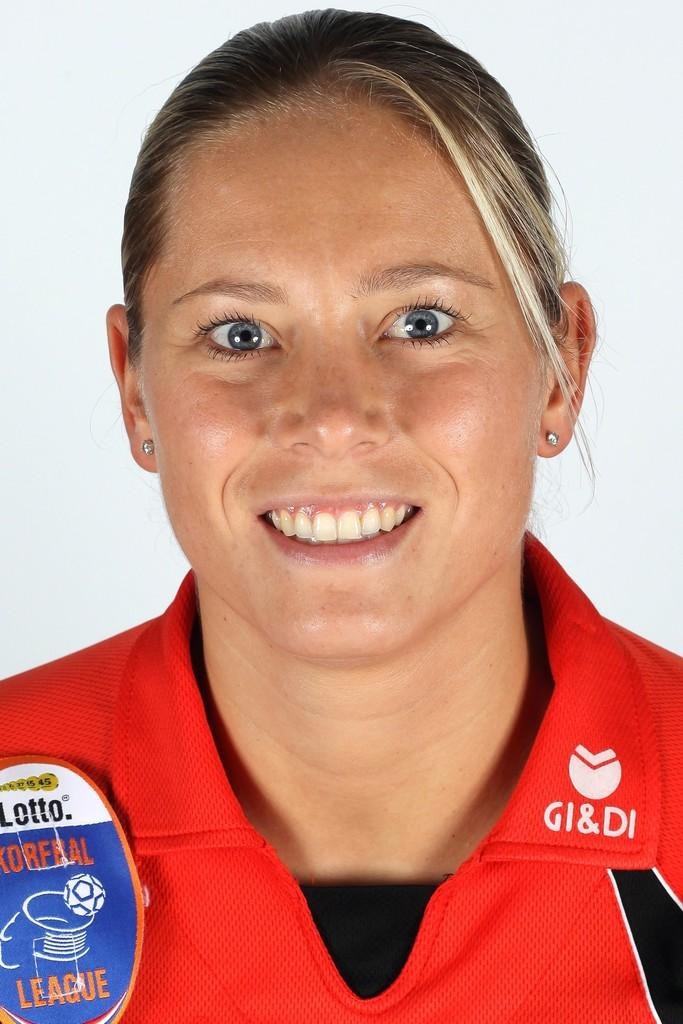<image>
Create a compact narrative representing the image presented. A lady in a red shirt with the letters GI&DI on the collar. 